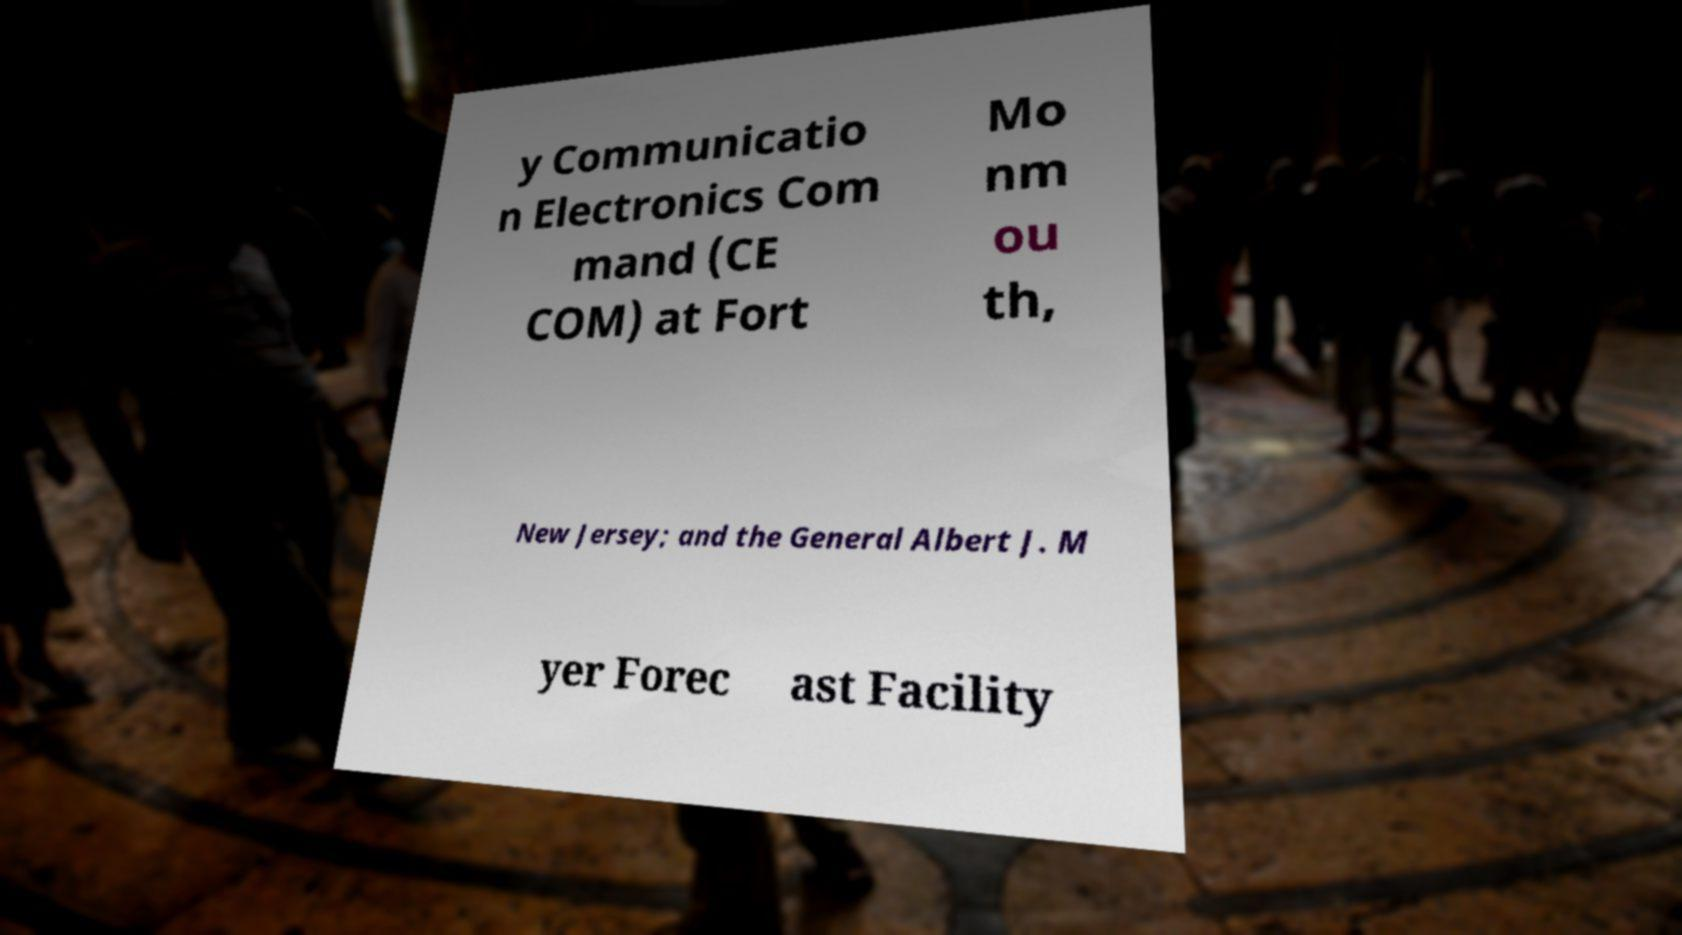There's text embedded in this image that I need extracted. Can you transcribe it verbatim? y Communicatio n Electronics Com mand (CE COM) at Fort Mo nm ou th, New Jersey; and the General Albert J. M yer Forec ast Facility 